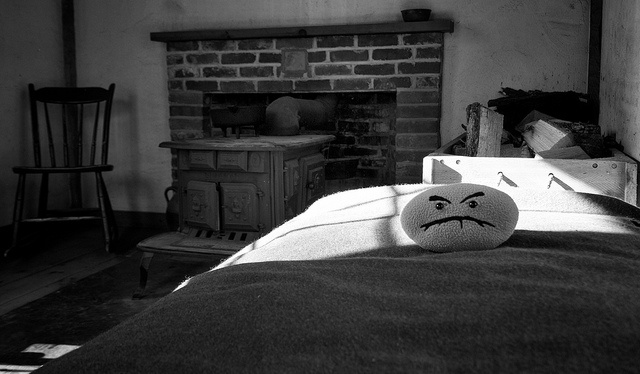Describe the objects in this image and their specific colors. I can see bed in black, white, gray, and darkgray tones and chair in black tones in this image. 